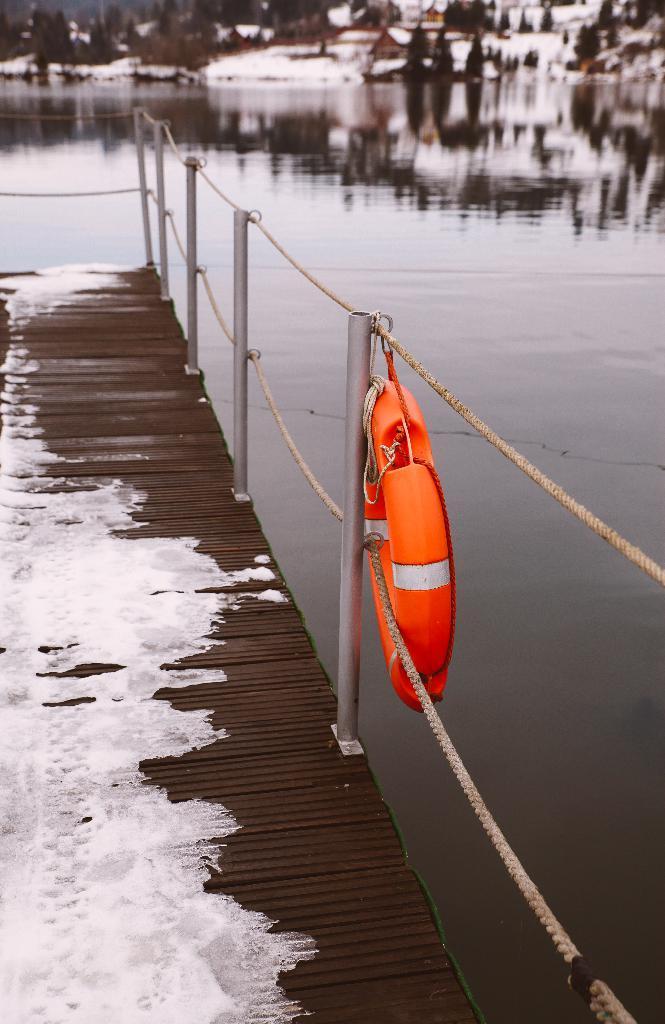Describe this image in one or two sentences. In the image I can see fence, wooden surface, the water, trees and some other objects. 